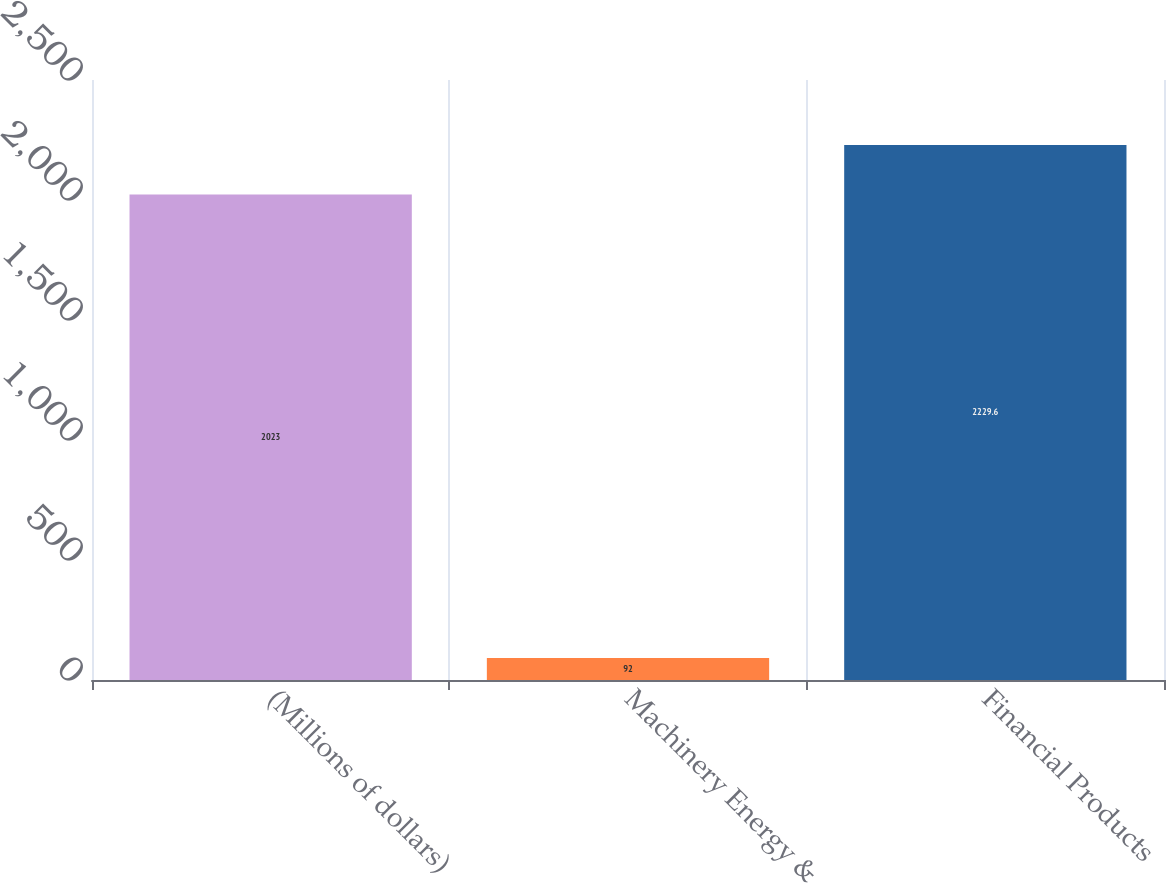Convert chart to OTSL. <chart><loc_0><loc_0><loc_500><loc_500><bar_chart><fcel>(Millions of dollars)<fcel>Machinery Energy &<fcel>Financial Products<nl><fcel>2023<fcel>92<fcel>2229.6<nl></chart> 